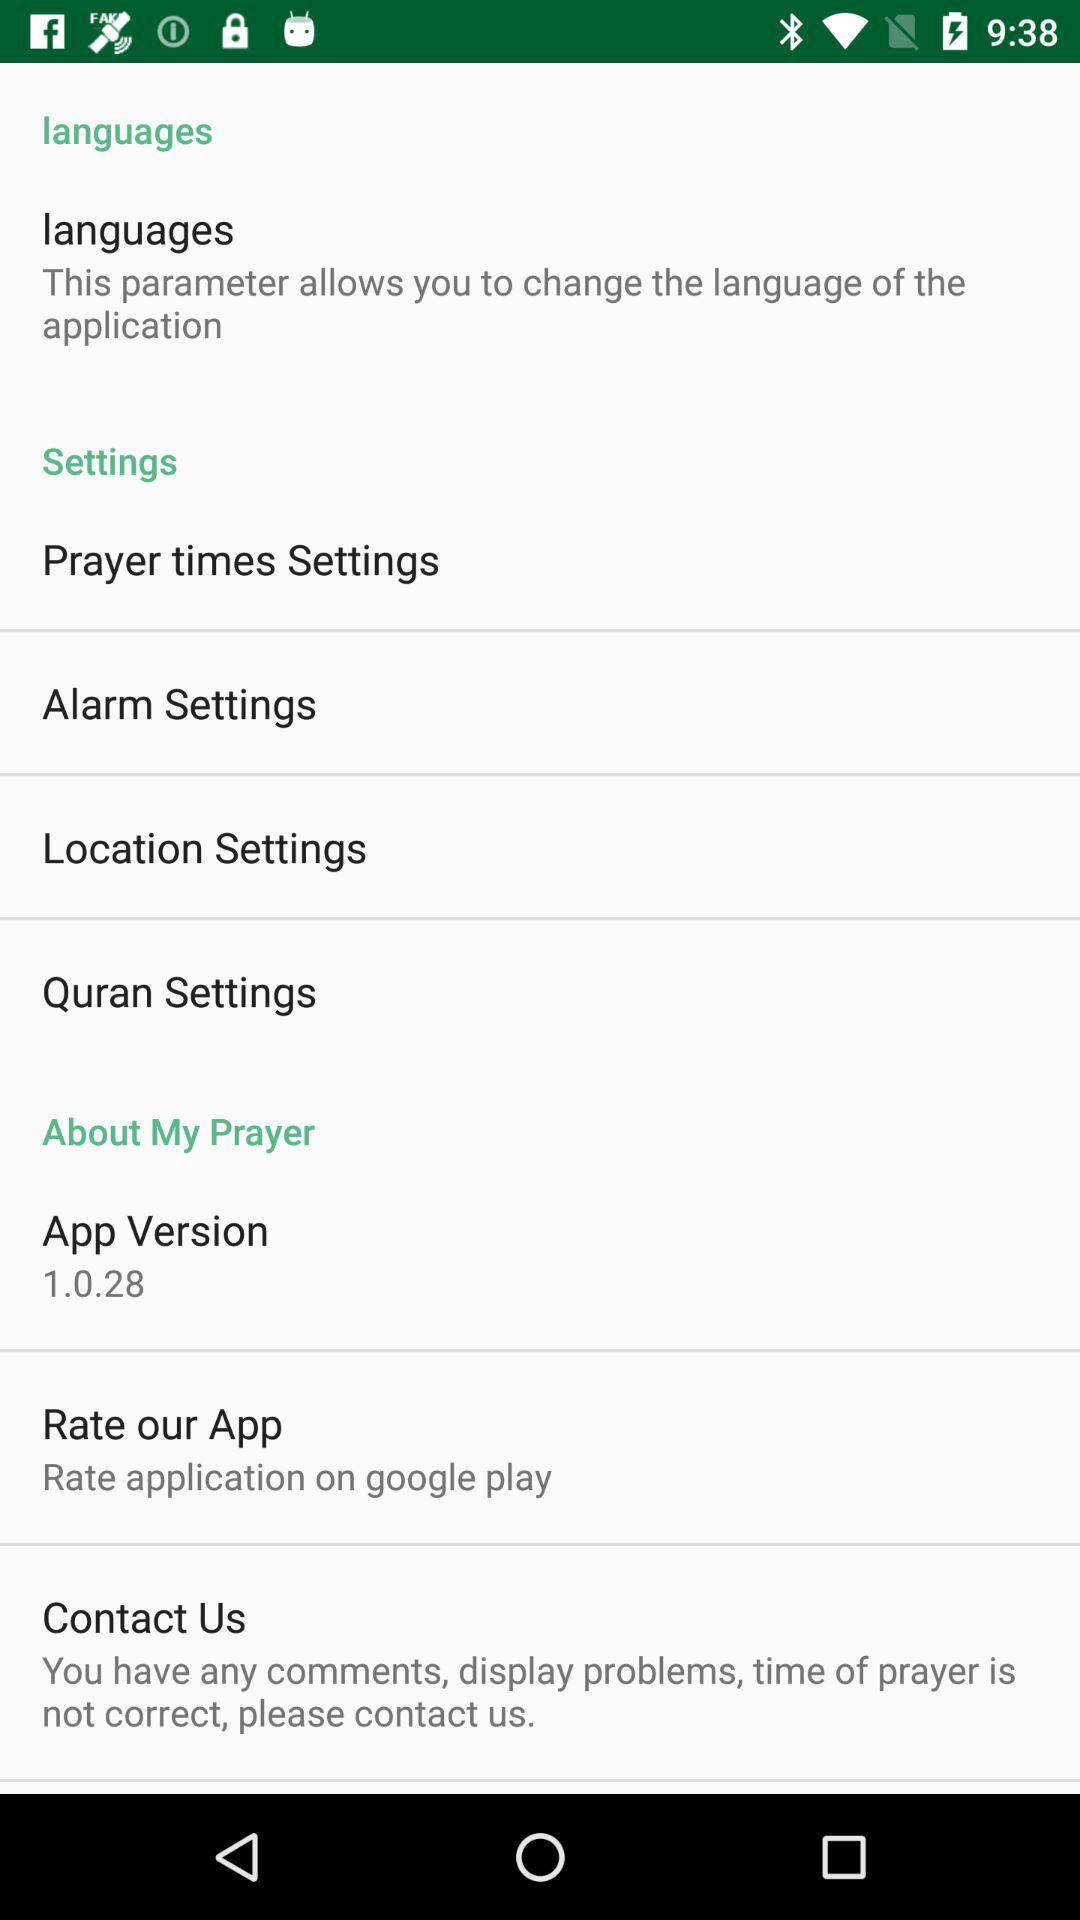How many items are in the About My Prayer section?
Answer the question using a single word or phrase. 3 